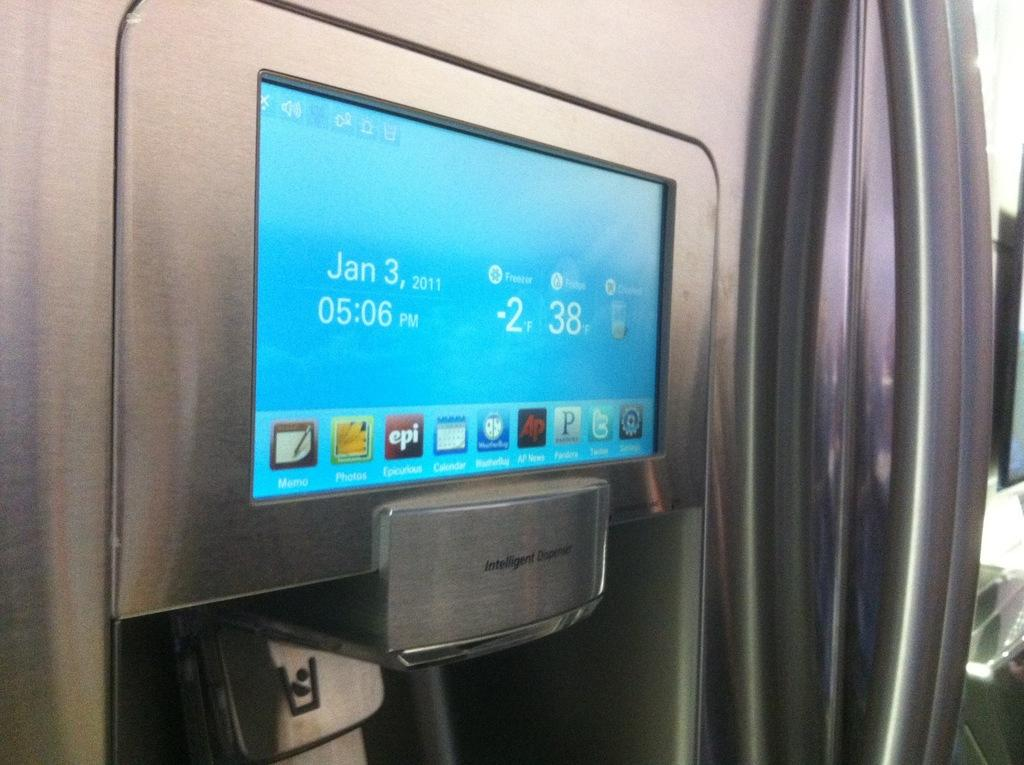What is the main object in the image? There is a display screen in the image. What is shown on the display screen? The display screen contains pictures and numbers. What type of device is the display screen on? The display screen is on a device. Where is the toothbrush located in the image? There is no toothbrush present in the image. What type of meat is being prepared on the display screen? There is no meat or cooking activity present in the image; it features a display screen with pictures and numbers. How is the cork being used in the image? There is no cork present in the image. 